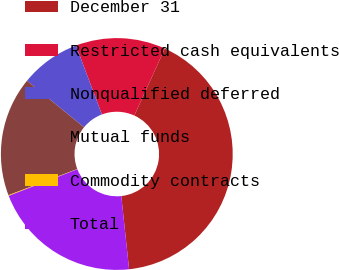<chart> <loc_0><loc_0><loc_500><loc_500><pie_chart><fcel>December 31<fcel>Restricted cash equivalents<fcel>Nonqualified deferred<fcel>Mutual funds<fcel>Commodity contracts<fcel>Total<nl><fcel>41.51%<fcel>12.53%<fcel>8.38%<fcel>16.67%<fcel>0.1%<fcel>20.81%<nl></chart> 